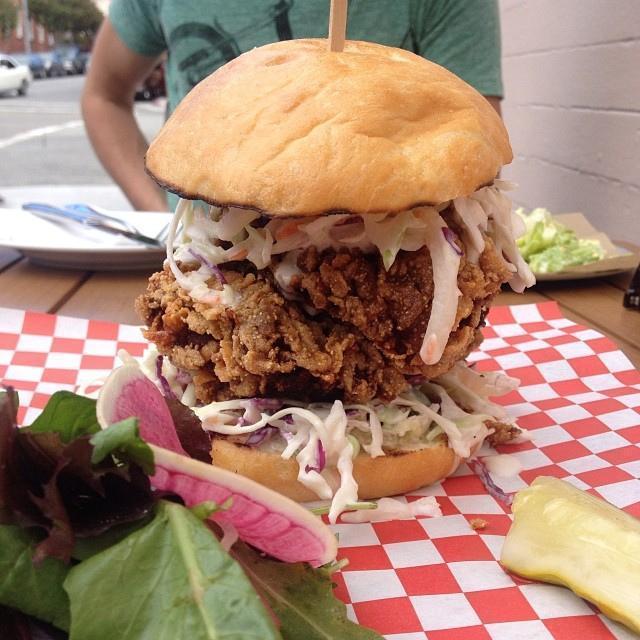How many dining tables are in the photo?
Give a very brief answer. 2. How many zebras can you see?
Give a very brief answer. 0. 